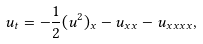<formula> <loc_0><loc_0><loc_500><loc_500>u _ { t } = - \frac { 1 } { 2 } ( u ^ { 2 } ) _ { x } - u _ { x x } - u _ { x x x x } ,</formula> 